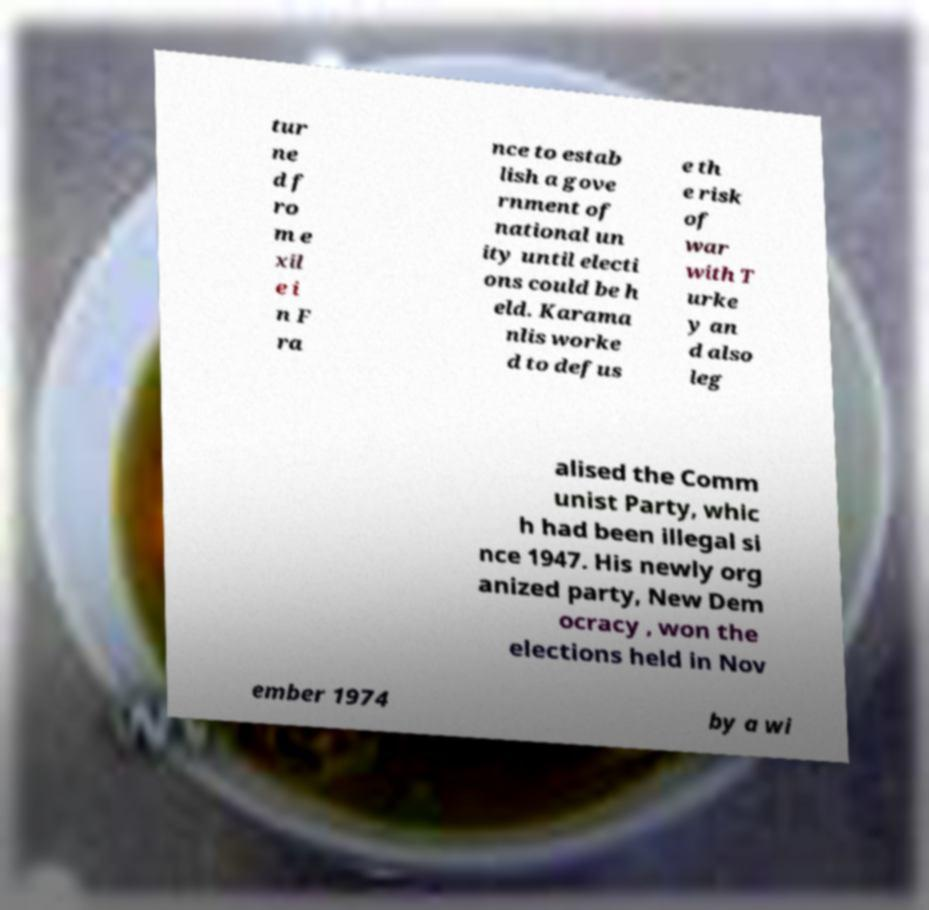Please read and relay the text visible in this image. What does it say? tur ne d f ro m e xil e i n F ra nce to estab lish a gove rnment of national un ity until electi ons could be h eld. Karama nlis worke d to defus e th e risk of war with T urke y an d also leg alised the Comm unist Party, whic h had been illegal si nce 1947. His newly org anized party, New Dem ocracy , won the elections held in Nov ember 1974 by a wi 